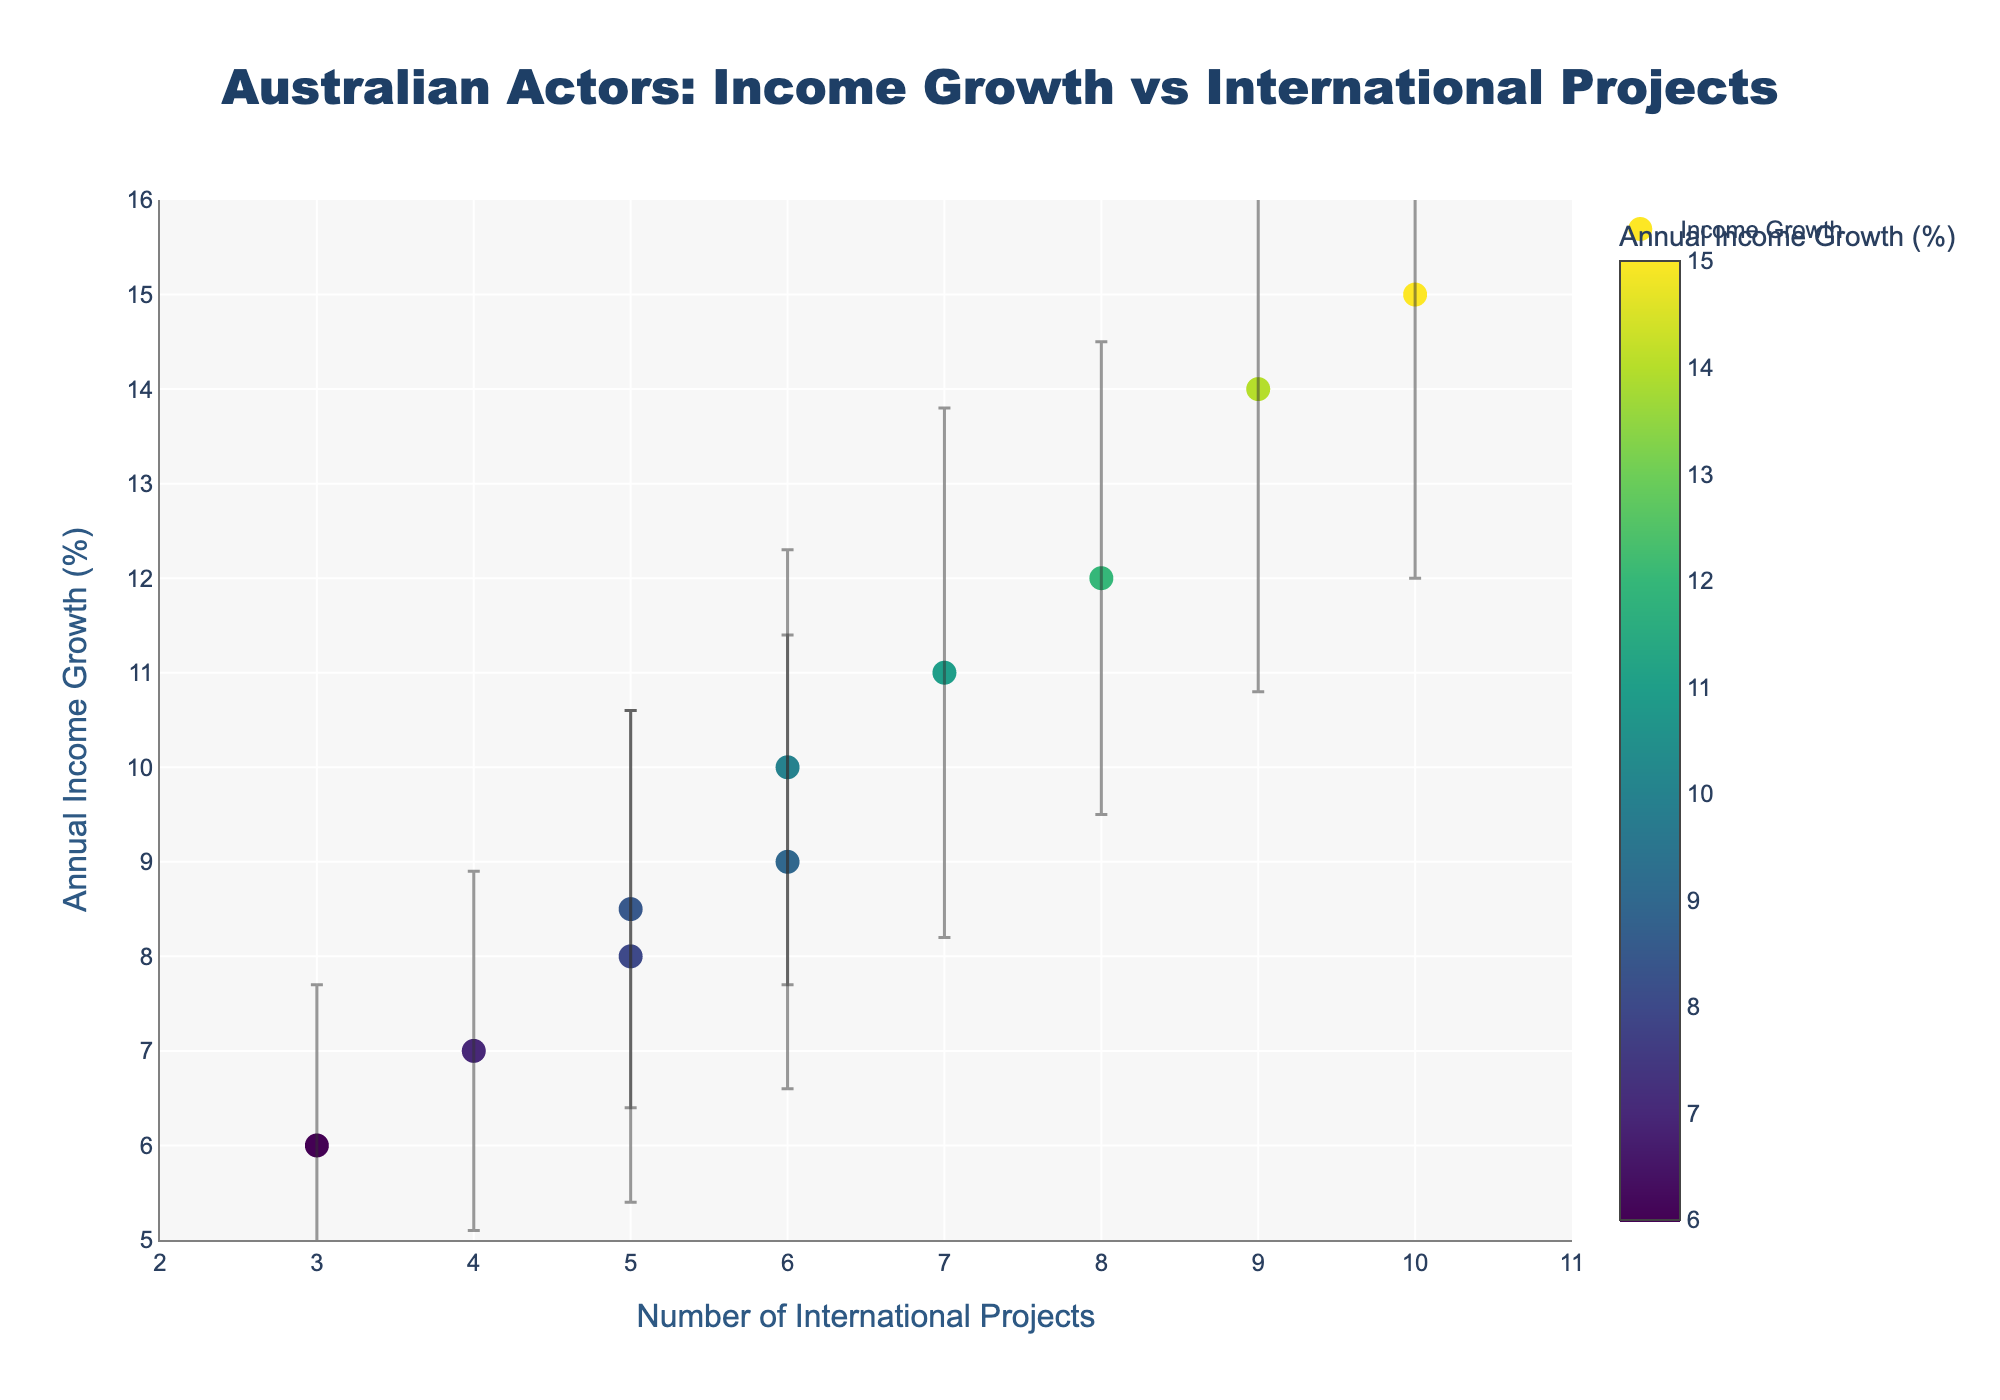What's the range of the x-axis? The x-axis title is "Number of International Projects", and the axis range is from 2 to 11 as indicated by the tick marks on the x-axis.
Answer: 2 to 11 How many actors have 6 international projects? By examining the plot and hovering over the points, we can see that two actors, Cate Blanchett and Rebel Wilson, have 6 international projects.
Answer: 2 Which actor has the highest annual income growth? Hovering over the highest point (y-axis value) shows that Hugh Jackman, with an annual income growth of 15%, has the highest income growth.
Answer: Hugh Jackman What is the income variance for the actor with the fewest international projects? Joel Edgerton has the fewest international projects (3). By hovering over his point, we see his income variance is 1.7%.
Answer: 1.7 Compare the annual income growth between the actors who undertook 5 international projects. Russell Crowe and Rose Byrne both undertook 5 international projects. Their annual income growth is 8% and 8.5%, respectively.
Answer: Rose Byrne: 8.5%, Russell Crowe: 8% What is the average annual income growth of all actors? Sum up the annual income growths (15 + 12 + 14 + 11 + 10 + 8 + 7 + 9 + 6 + 8.5) = 100.5. There are 10 actors, so the average is 100.5 / 10 = 10.05%.
Answer: 10.05% Which actor has the highest income variance, and what is its value? Chris Hemsworth has the highest income variance, with a value of 3.2%, as seen by hovering over his data point.
Answer: Chris Hemsworth, 3.2% What is the difference in annual income growth between Nicole Kidman and Margot Robbie? Nicole Kidman's annual income growth is 12%, and Margot Robbie's is 11%. The difference is 12% - 11% = 1%.
Answer: 1% What is the title of the figure? The title of the figure is displayed at the top and reads "Australian Actors: Income Growth vs International Projects."
Answer: Australian Actors: Income Growth vs International Projects Describe the color scheme used to represent the annual income growth. The markers use a Viridis color scale, ranging from cooler colors (low income growth) to warmer colors (high income growth), as indicated by the color scale bar on the right side of the plot.
Answer: Viridis color scale 